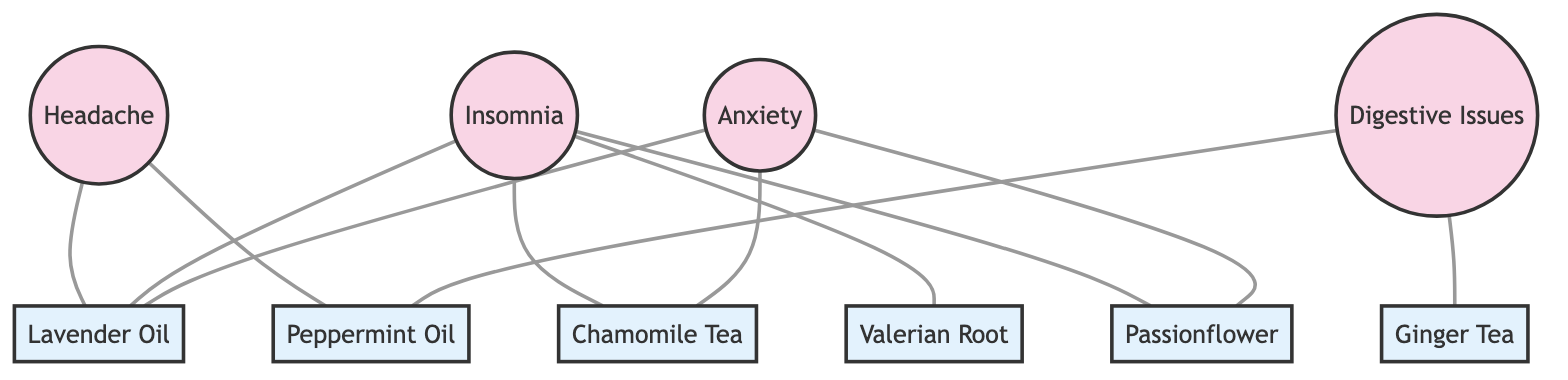What's the total number of nodes in the diagram? The diagram features 10 different nodes representing both symptoms and remedies, which include various forms of herbal treatments and essential oils.
Answer: 10 Which symptom is connected to Chamomile Tea? From the diagram, Chamomile Tea is directly connected to both Insomnia and Anxiety, indicating these symptoms can be alleviated with this remedy.
Answer: Insomnia, Anxiety How many symptoms are connected to Lavender Oil? By examining the edges connected to Lavender Oil, we see it connects to three symptoms: Headache, Insomnia, and Anxiety.
Answer: 3 Which remedy is associated with Digestive Issues? The remedy connected to Digestive Issues is Peppermint Oil and Ginger Tea, suggesting they may help alleviate this particular symptom.
Answer: Peppermint Oil, Ginger Tea Are there any remedies associated with both anxiety and insomnia? Analyzing the connections, we find that Lavender Oil, Chamomile Tea, and Passionflower are associated with both Anxiety and Insomnia symptoms.
Answer: Lavender Oil, Chamomile Tea, Passionflower What is the degree of the Insomnia node? The degree of the Insomnia node is determined by counting its edges; Insomnia connects to Lavender Oil, Chamomile Tea, Valerian Root, and Passionflower, which makes it have a degree of 4.
Answer: 4 Which remedy is exclusively linked to only one symptom? By checking the connections, Ginger Tea is exclusively connected to Digestive Issues, indicating it has no other associations within the graph.
Answer: Ginger Tea How many edges are connected to the Headache node? The Headache node has connections with two edges; it links with Lavender Oil and Peppermint Oil only, meaning it relates to two specific remedies.
Answer: 2 Which symptom is connected to the most number of remedies? Insomnia is connected to four remedies: Lavender Oil, Chamomile Tea, Valerian Root, and Passionflower, making it the symptom with the most connections.
Answer: Insomnia 